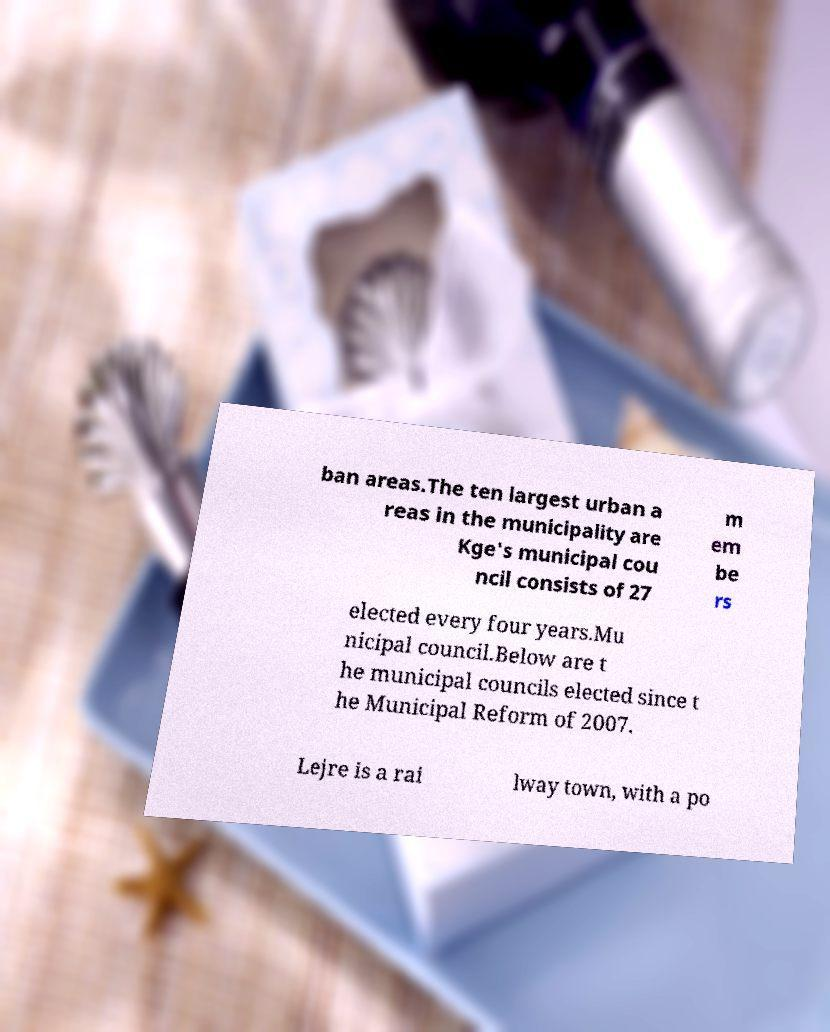Could you assist in decoding the text presented in this image and type it out clearly? ban areas.The ten largest urban a reas in the municipality are Kge's municipal cou ncil consists of 27 m em be rs elected every four years.Mu nicipal council.Below are t he municipal councils elected since t he Municipal Reform of 2007. Lejre is a rai lway town, with a po 